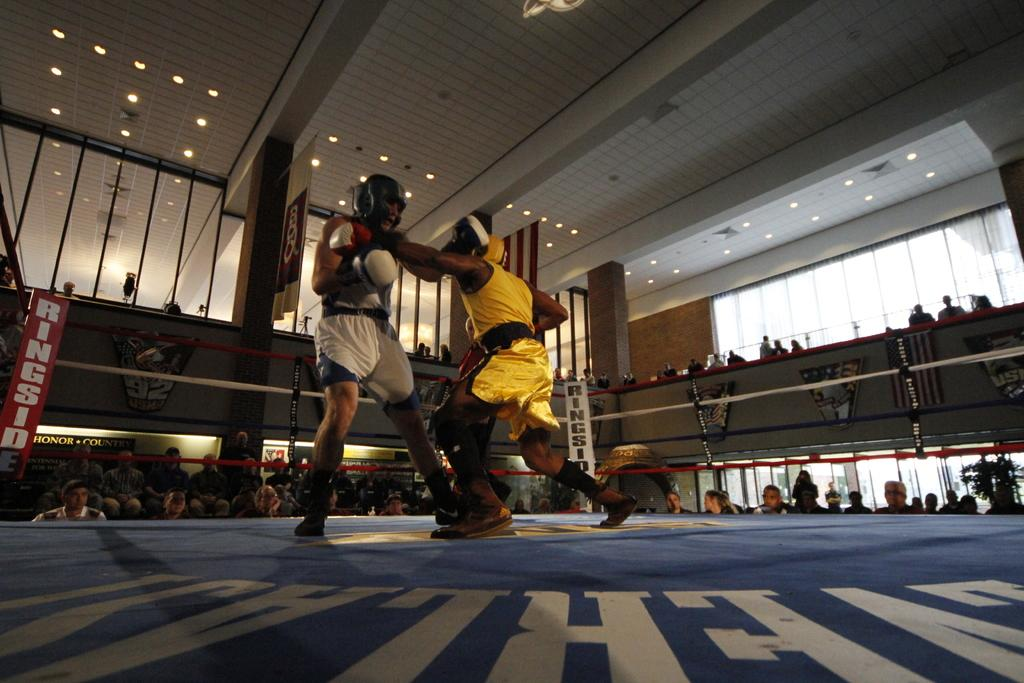<image>
Give a short and clear explanation of the subsequent image. Two boxers spar in a ring while displays in the back read RINGSIDE. 